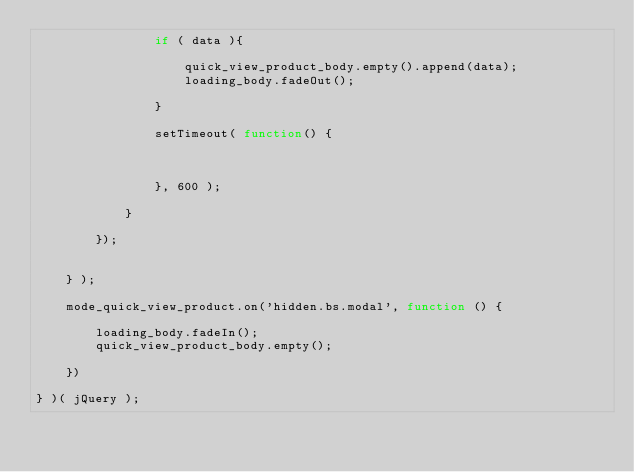<code> <loc_0><loc_0><loc_500><loc_500><_JavaScript_>                if ( data ){

                    quick_view_product_body.empty().append(data);
                    loading_body.fadeOut();

                }

                setTimeout( function() {



                }, 600 );

            }

        });


    } );

    mode_quick_view_product.on('hidden.bs.modal', function () {

        loading_body.fadeIn();
        quick_view_product_body.empty();

    })

} )( jQuery );</code> 